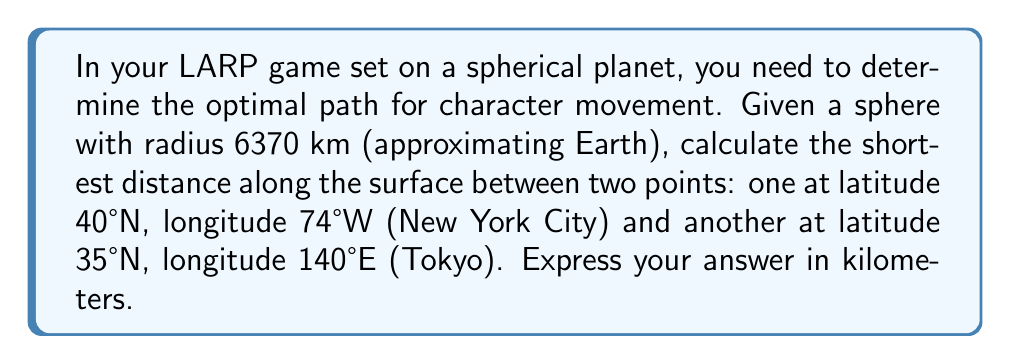Show me your answer to this math problem. To solve this problem, we'll use the Great Circle Distance formula, which gives the shortest path between two points on a sphere. Here's the step-by-step solution:

1. Convert the coordinates to radians:
   New York: $\phi_1 = 40° \cdot \frac{\pi}{180} = 0.6981$ rad, $\lambda_1 = -74° \cdot \frac{\pi}{180} = -1.2915$ rad
   Tokyo: $\phi_2 = 35° \cdot \frac{\pi}{180} = 0.6109$ rad, $\lambda_2 = 140° \cdot \frac{\pi}{180} = 2.4435$ rad

2. Calculate the central angle $\Delta\sigma$ using the Haversine formula:
   $$\Delta\sigma = 2 \arcsin\left(\sqrt{\sin^2\left(\frac{\phi_2 - \phi_1}{2}\right) + \cos(\phi_1)\cos(\phi_2)\sin^2\left(\frac{\lambda_2 - \lambda_1}{2}\right)}\right)$$

3. Substitute the values:
   $$\Delta\sigma = 2 \arcsin\left(\sqrt{\sin^2\left(\frac{0.6109 - 0.6981}{2}\right) + \cos(0.6981)\cos(0.6109)\sin^2\left(\frac{2.4435 - (-1.2915)}{2}\right)}\right)$$

4. Evaluate:
   $$\Delta\sigma = 2 \arcsin(\sqrt{0.0019 + 0.7071 \cdot 0.7660 \cdot 0.8903}) = 1.9635$$

5. Calculate the distance $d$ along the great circle:
   $$d = R \cdot \Delta\sigma$$
   where $R$ is the radius of the sphere (6370 km)

6. Substitute and calculate:
   $$d = 6370 \cdot 1.9635 = 12507.5 \text{ km}$$

Therefore, the shortest distance along the surface between New York City and Tokyo is approximately 12,507.5 km.
Answer: 12,507.5 km 